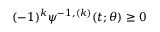Convert formula to latex. <formula><loc_0><loc_0><loc_500><loc_500>( - 1 ) ^ { k } \psi ^ { - 1 , ( k ) } ( t ; \theta ) \geq 0</formula> 